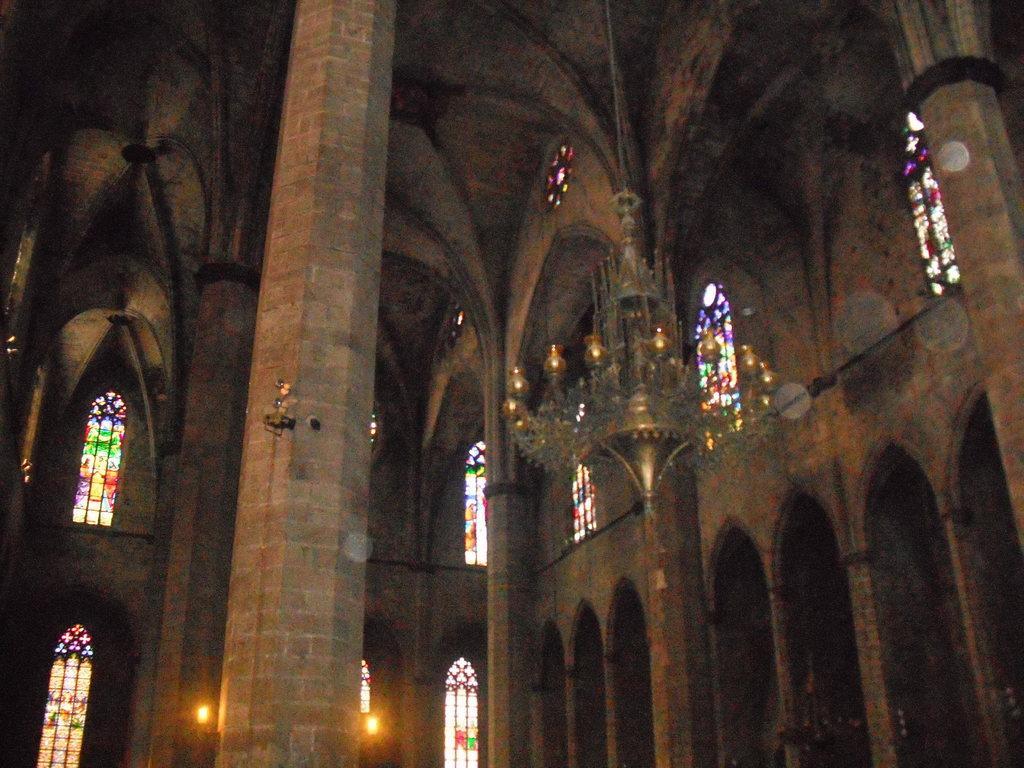Can you describe this image briefly? In this picture we can see a chandelier, pillars, lights and this is an inside view of a building. 